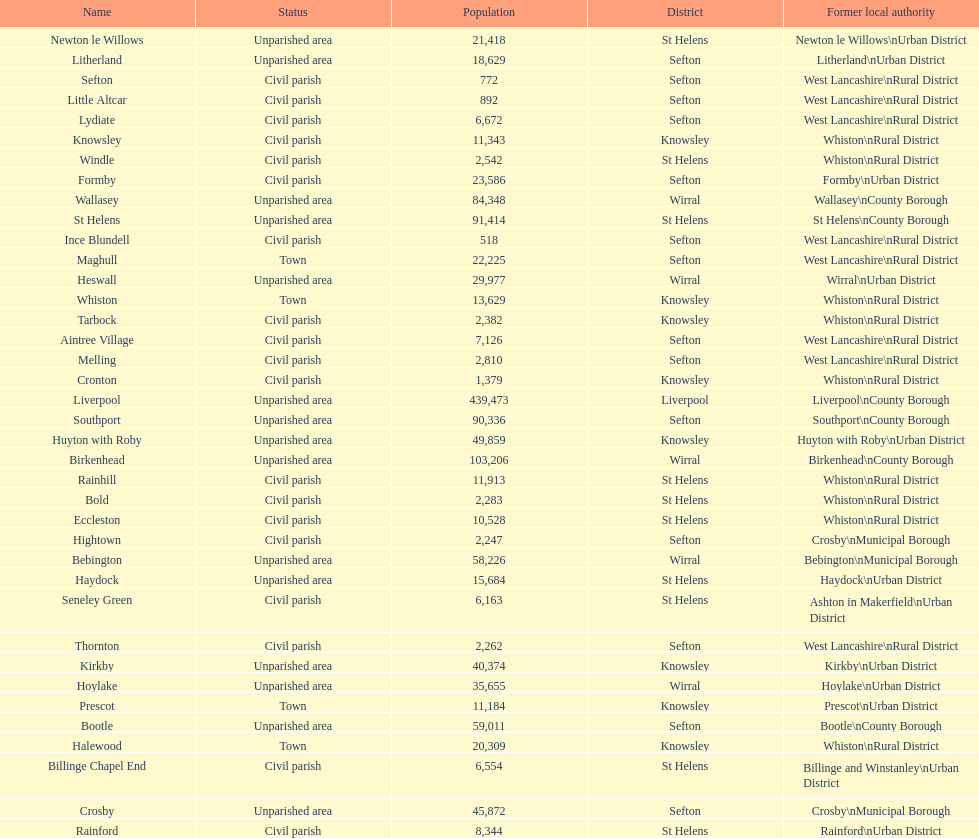Help me parse the entirety of this table. {'header': ['Name', 'Status', 'Population', 'District', 'Former local authority'], 'rows': [['Newton le Willows', 'Unparished area', '21,418', 'St Helens', 'Newton le Willows\\nUrban District'], ['Litherland', 'Unparished area', '18,629', 'Sefton', 'Litherland\\nUrban District'], ['Sefton', 'Civil parish', '772', 'Sefton', 'West Lancashire\\nRural District'], ['Little Altcar', 'Civil parish', '892', 'Sefton', 'West Lancashire\\nRural District'], ['Lydiate', 'Civil parish', '6,672', 'Sefton', 'West Lancashire\\nRural District'], ['Knowsley', 'Civil parish', '11,343', 'Knowsley', 'Whiston\\nRural District'], ['Windle', 'Civil parish', '2,542', 'St Helens', 'Whiston\\nRural District'], ['Formby', 'Civil parish', '23,586', 'Sefton', 'Formby\\nUrban District'], ['Wallasey', 'Unparished area', '84,348', 'Wirral', 'Wallasey\\nCounty Borough'], ['St Helens', 'Unparished area', '91,414', 'St Helens', 'St Helens\\nCounty Borough'], ['Ince Blundell', 'Civil parish', '518', 'Sefton', 'West Lancashire\\nRural District'], ['Maghull', 'Town', '22,225', 'Sefton', 'West Lancashire\\nRural District'], ['Heswall', 'Unparished area', '29,977', 'Wirral', 'Wirral\\nUrban District'], ['Whiston', 'Town', '13,629', 'Knowsley', 'Whiston\\nRural District'], ['Tarbock', 'Civil parish', '2,382', 'Knowsley', 'Whiston\\nRural District'], ['Aintree Village', 'Civil parish', '7,126', 'Sefton', 'West Lancashire\\nRural District'], ['Melling', 'Civil parish', '2,810', 'Sefton', 'West Lancashire\\nRural District'], ['Cronton', 'Civil parish', '1,379', 'Knowsley', 'Whiston\\nRural District'], ['Liverpool', 'Unparished area', '439,473', 'Liverpool', 'Liverpool\\nCounty Borough'], ['Southport', 'Unparished area', '90,336', 'Sefton', 'Southport\\nCounty Borough'], ['Huyton with Roby', 'Unparished area', '49,859', 'Knowsley', 'Huyton with Roby\\nUrban District'], ['Birkenhead', 'Unparished area', '103,206', 'Wirral', 'Birkenhead\\nCounty Borough'], ['Rainhill', 'Civil parish', '11,913', 'St Helens', 'Whiston\\nRural District'], ['Bold', 'Civil parish', '2,283', 'St Helens', 'Whiston\\nRural District'], ['Eccleston', 'Civil parish', '10,528', 'St Helens', 'Whiston\\nRural District'], ['Hightown', 'Civil parish', '2,247', 'Sefton', 'Crosby\\nMunicipal Borough'], ['Bebington', 'Unparished area', '58,226', 'Wirral', 'Bebington\\nMunicipal Borough'], ['Haydock', 'Unparished area', '15,684', 'St Helens', 'Haydock\\nUrban District'], ['Seneley Green', 'Civil parish', '6,163', 'St Helens', 'Ashton in Makerfield\\nUrban District'], ['Thornton', 'Civil parish', '2,262', 'Sefton', 'West Lancashire\\nRural District'], ['Kirkby', 'Unparished area', '40,374', 'Knowsley', 'Kirkby\\nUrban District'], ['Hoylake', 'Unparished area', '35,655', 'Wirral', 'Hoylake\\nUrban District'], ['Prescot', 'Town', '11,184', 'Knowsley', 'Prescot\\nUrban District'], ['Bootle', 'Unparished area', '59,011', 'Sefton', 'Bootle\\nCounty Borough'], ['Halewood', 'Town', '20,309', 'Knowsley', 'Whiston\\nRural District'], ['Billinge Chapel End', 'Civil parish', '6,554', 'St Helens', 'Billinge and Winstanley\\nUrban District'], ['Crosby', 'Unparished area', '45,872', 'Sefton', 'Crosby\\nMunicipal Borough'], ['Rainford', 'Civil parish', '8,344', 'St Helens', 'Rainford\\nUrban District']]} Which is a civil parish, aintree village or maghull? Aintree Village. 